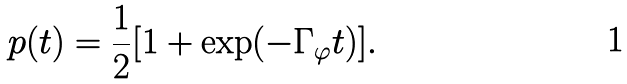Convert formula to latex. <formula><loc_0><loc_0><loc_500><loc_500>p ( t ) = \frac { 1 } { 2 } [ 1 + \exp ( - \Gamma _ { \varphi } t ) ] .</formula> 